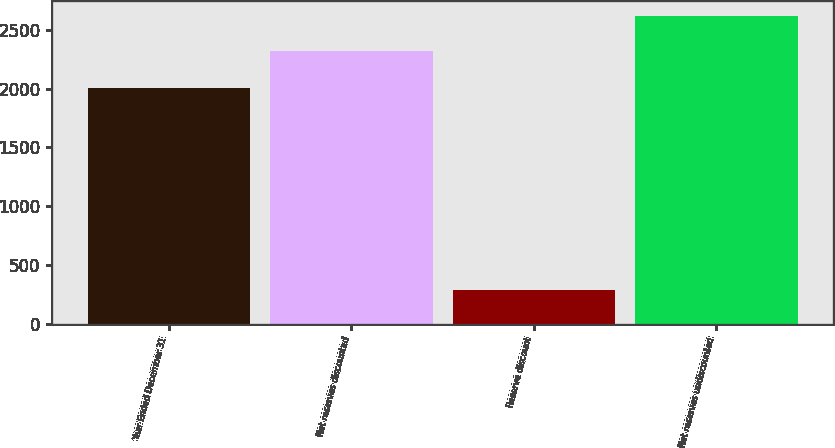Convert chart. <chart><loc_0><loc_0><loc_500><loc_500><bar_chart><fcel>Year Ended December 31<fcel>Net reserves discounted<fcel>Reserve discount<fcel>Net reserves undiscounted<nl><fcel>2002<fcel>2323<fcel>293<fcel>2616<nl></chart> 